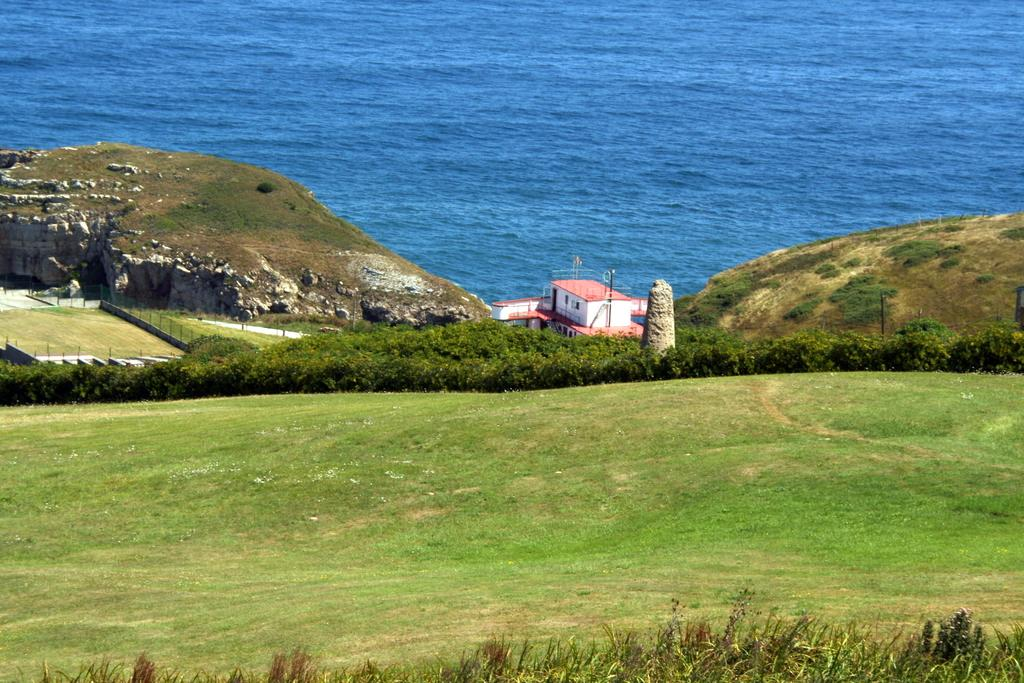What type of structure is present in the image? There is a building in the image. What can be seen on the hill in the image? There are plants on a hill in the image. What is located at the bottom of the image? There are other plants at the bottom of the image. What natural feature is visible at the top of the image? There is a sea visible at the top of the image. What type of plants were discovered on the hill in the image? There is no mention of a discovery in the image; the plants on the hill are simply visible. What type of wilderness is depicted in the image? The image does not depict a wilderness; it features a building, plants, and a sea. 